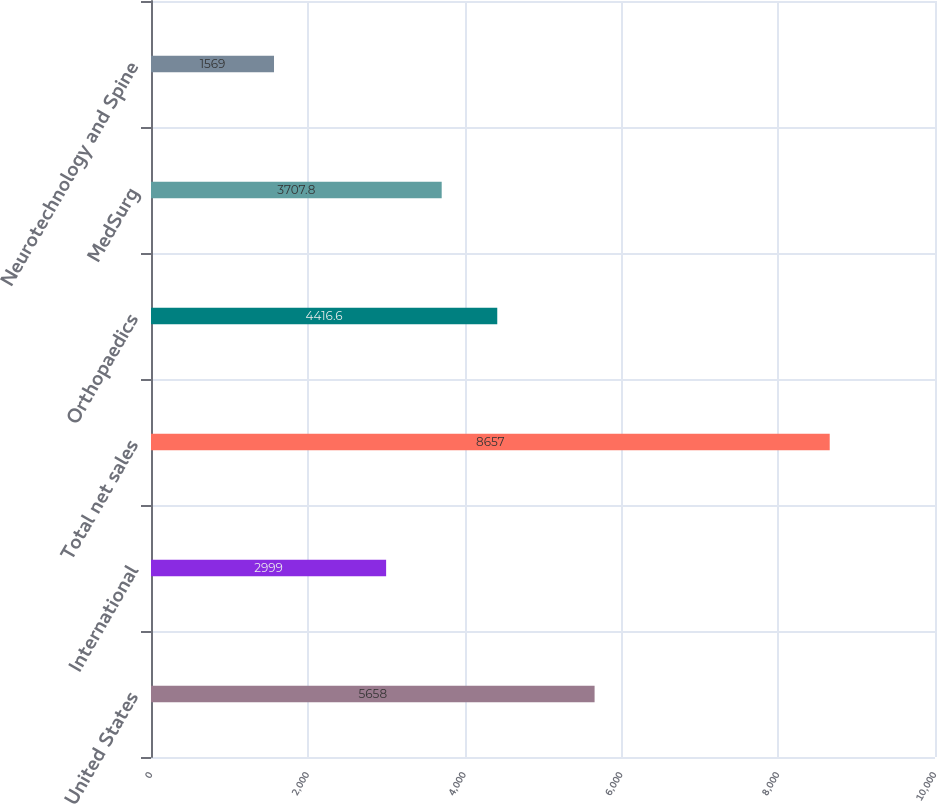<chart> <loc_0><loc_0><loc_500><loc_500><bar_chart><fcel>United States<fcel>International<fcel>Total net sales<fcel>Orthopaedics<fcel>MedSurg<fcel>Neurotechnology and Spine<nl><fcel>5658<fcel>2999<fcel>8657<fcel>4416.6<fcel>3707.8<fcel>1569<nl></chart> 